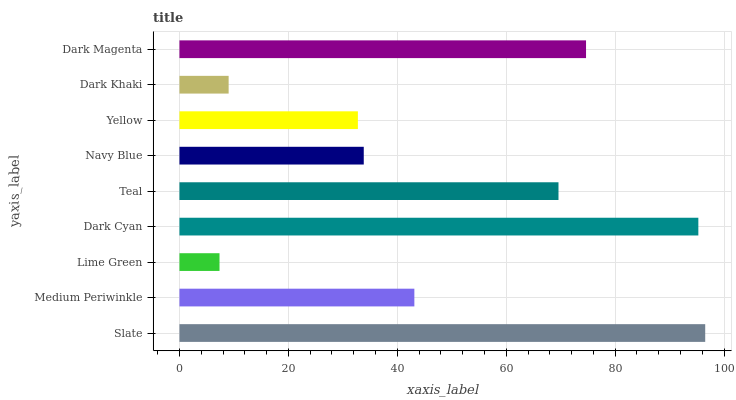Is Lime Green the minimum?
Answer yes or no. Yes. Is Slate the maximum?
Answer yes or no. Yes. Is Medium Periwinkle the minimum?
Answer yes or no. No. Is Medium Periwinkle the maximum?
Answer yes or no. No. Is Slate greater than Medium Periwinkle?
Answer yes or no. Yes. Is Medium Periwinkle less than Slate?
Answer yes or no. Yes. Is Medium Periwinkle greater than Slate?
Answer yes or no. No. Is Slate less than Medium Periwinkle?
Answer yes or no. No. Is Medium Periwinkle the high median?
Answer yes or no. Yes. Is Medium Periwinkle the low median?
Answer yes or no. Yes. Is Navy Blue the high median?
Answer yes or no. No. Is Lime Green the low median?
Answer yes or no. No. 